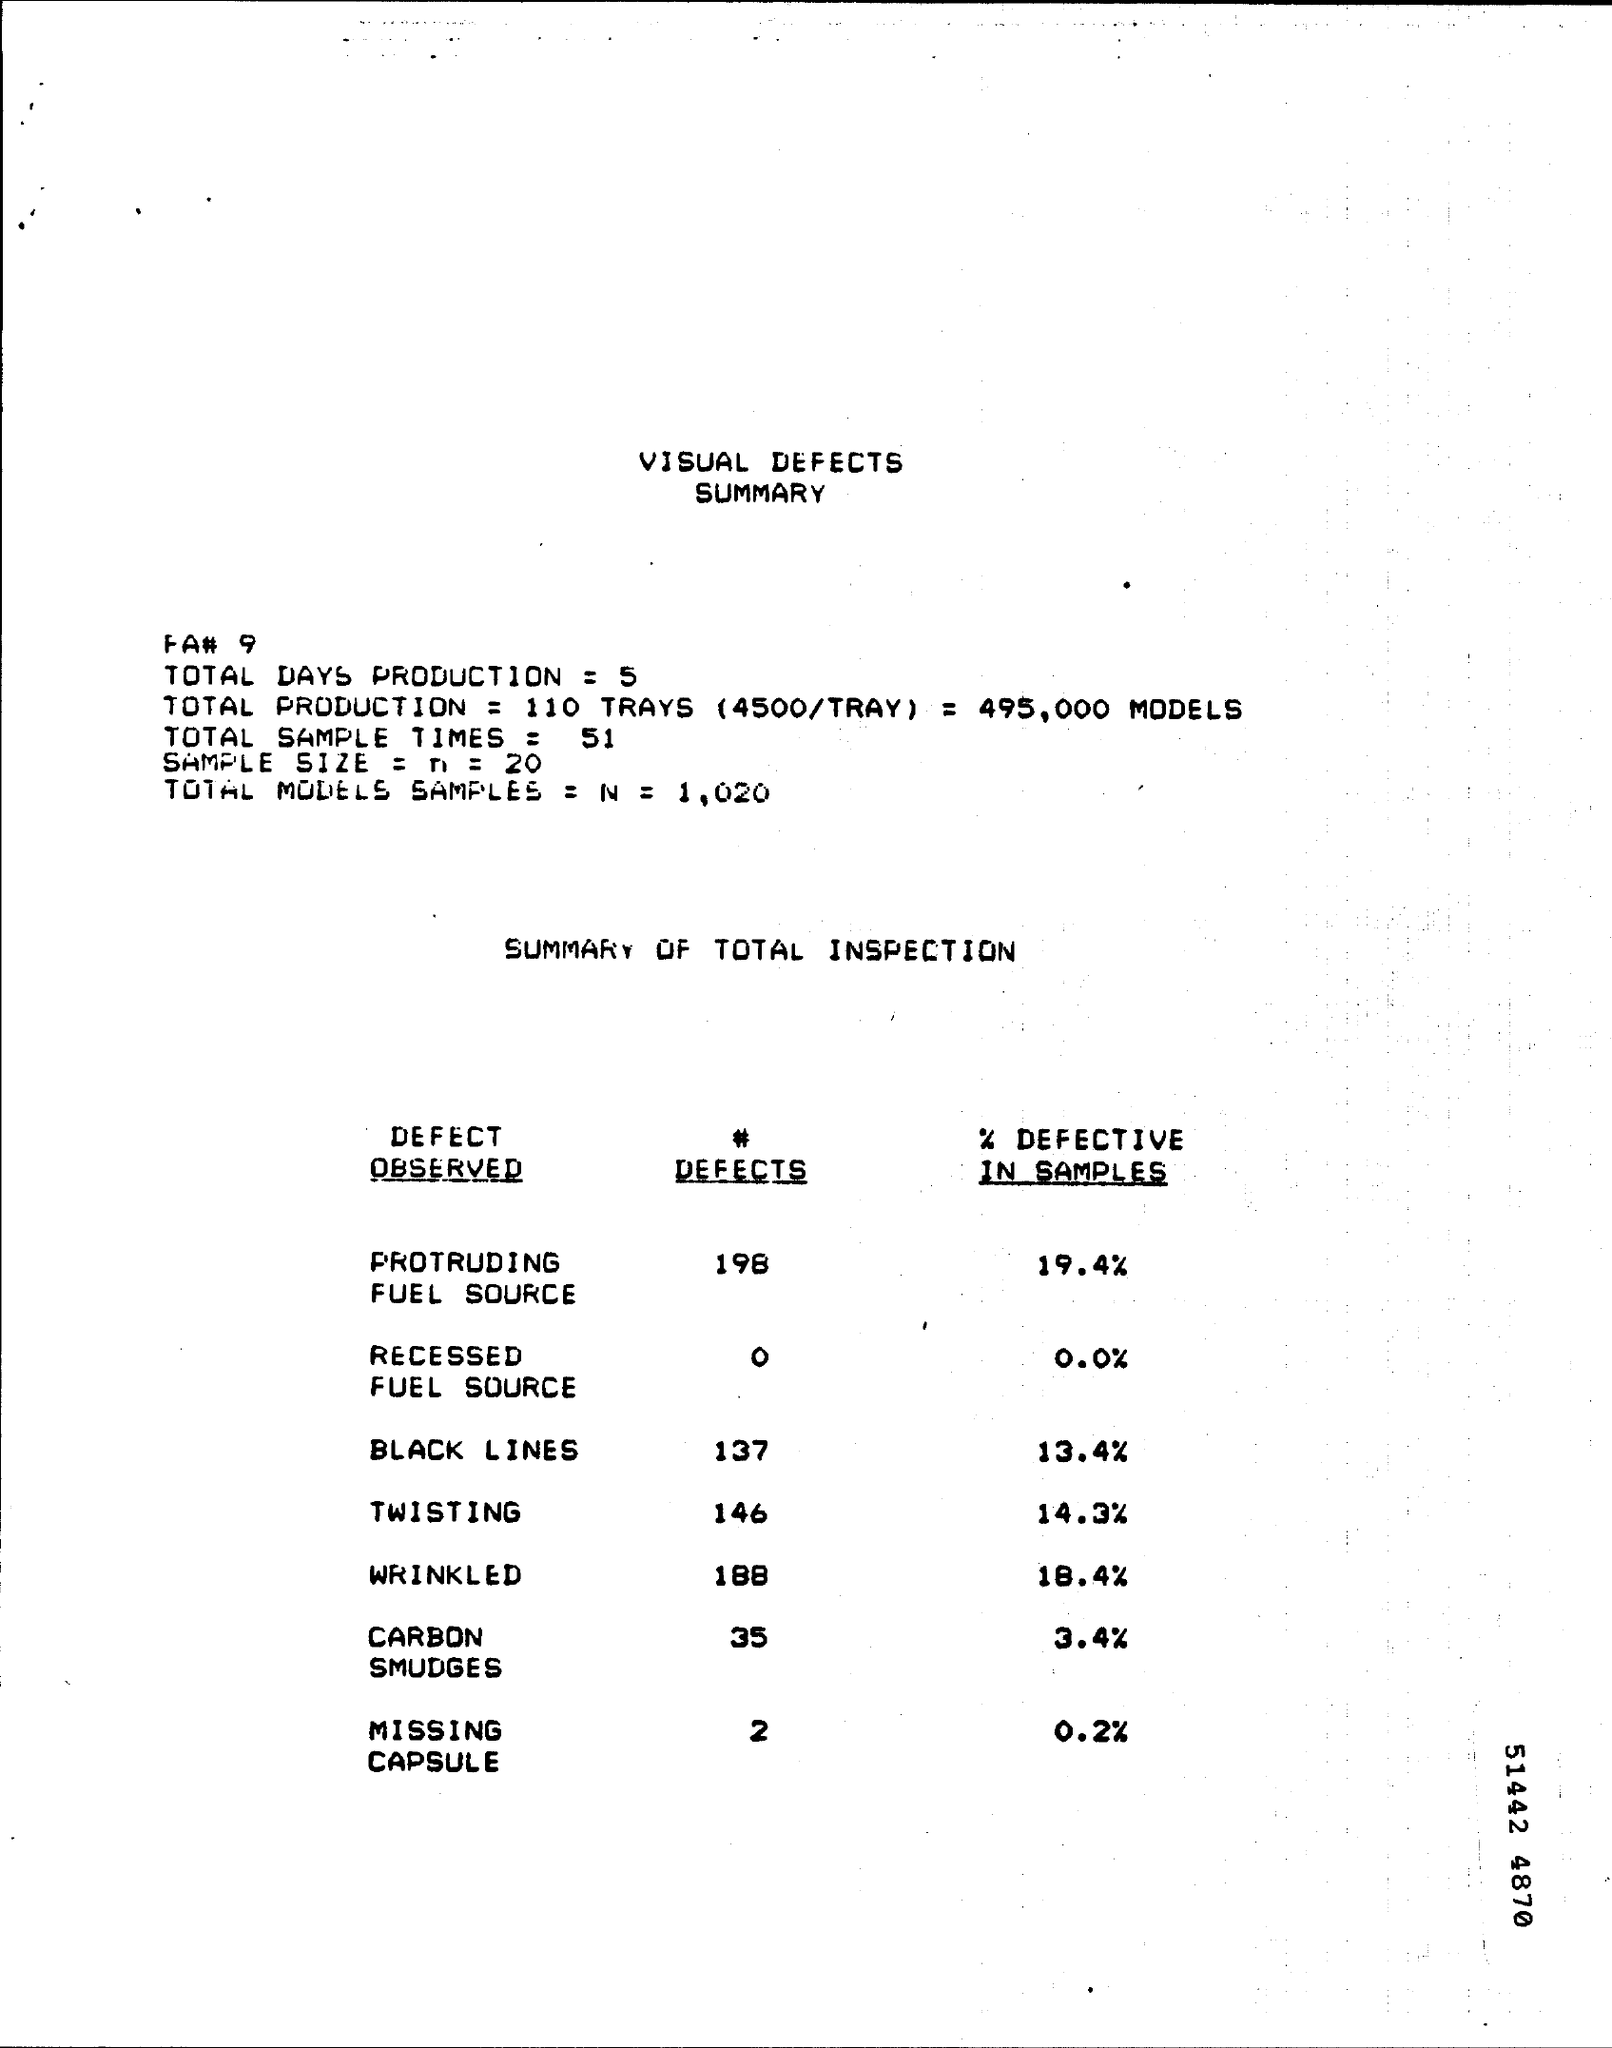What is the Title of the document?
Keep it short and to the point. VISUAL DEFECTS SUMMARY. What is the Total Days Production?
Your answer should be very brief. 5. What is the Total Sample Times?
Your answer should be compact. 51. How many # Defects of Twisting?
Your answer should be very brief. 146. How many # Defects of Wrinkled?
Your answer should be very brief. 188. How many # Defects of Carbon Smudges?
Offer a very short reply. 35. How many # Defects of Missing Capsule?
Offer a terse response. 2. 